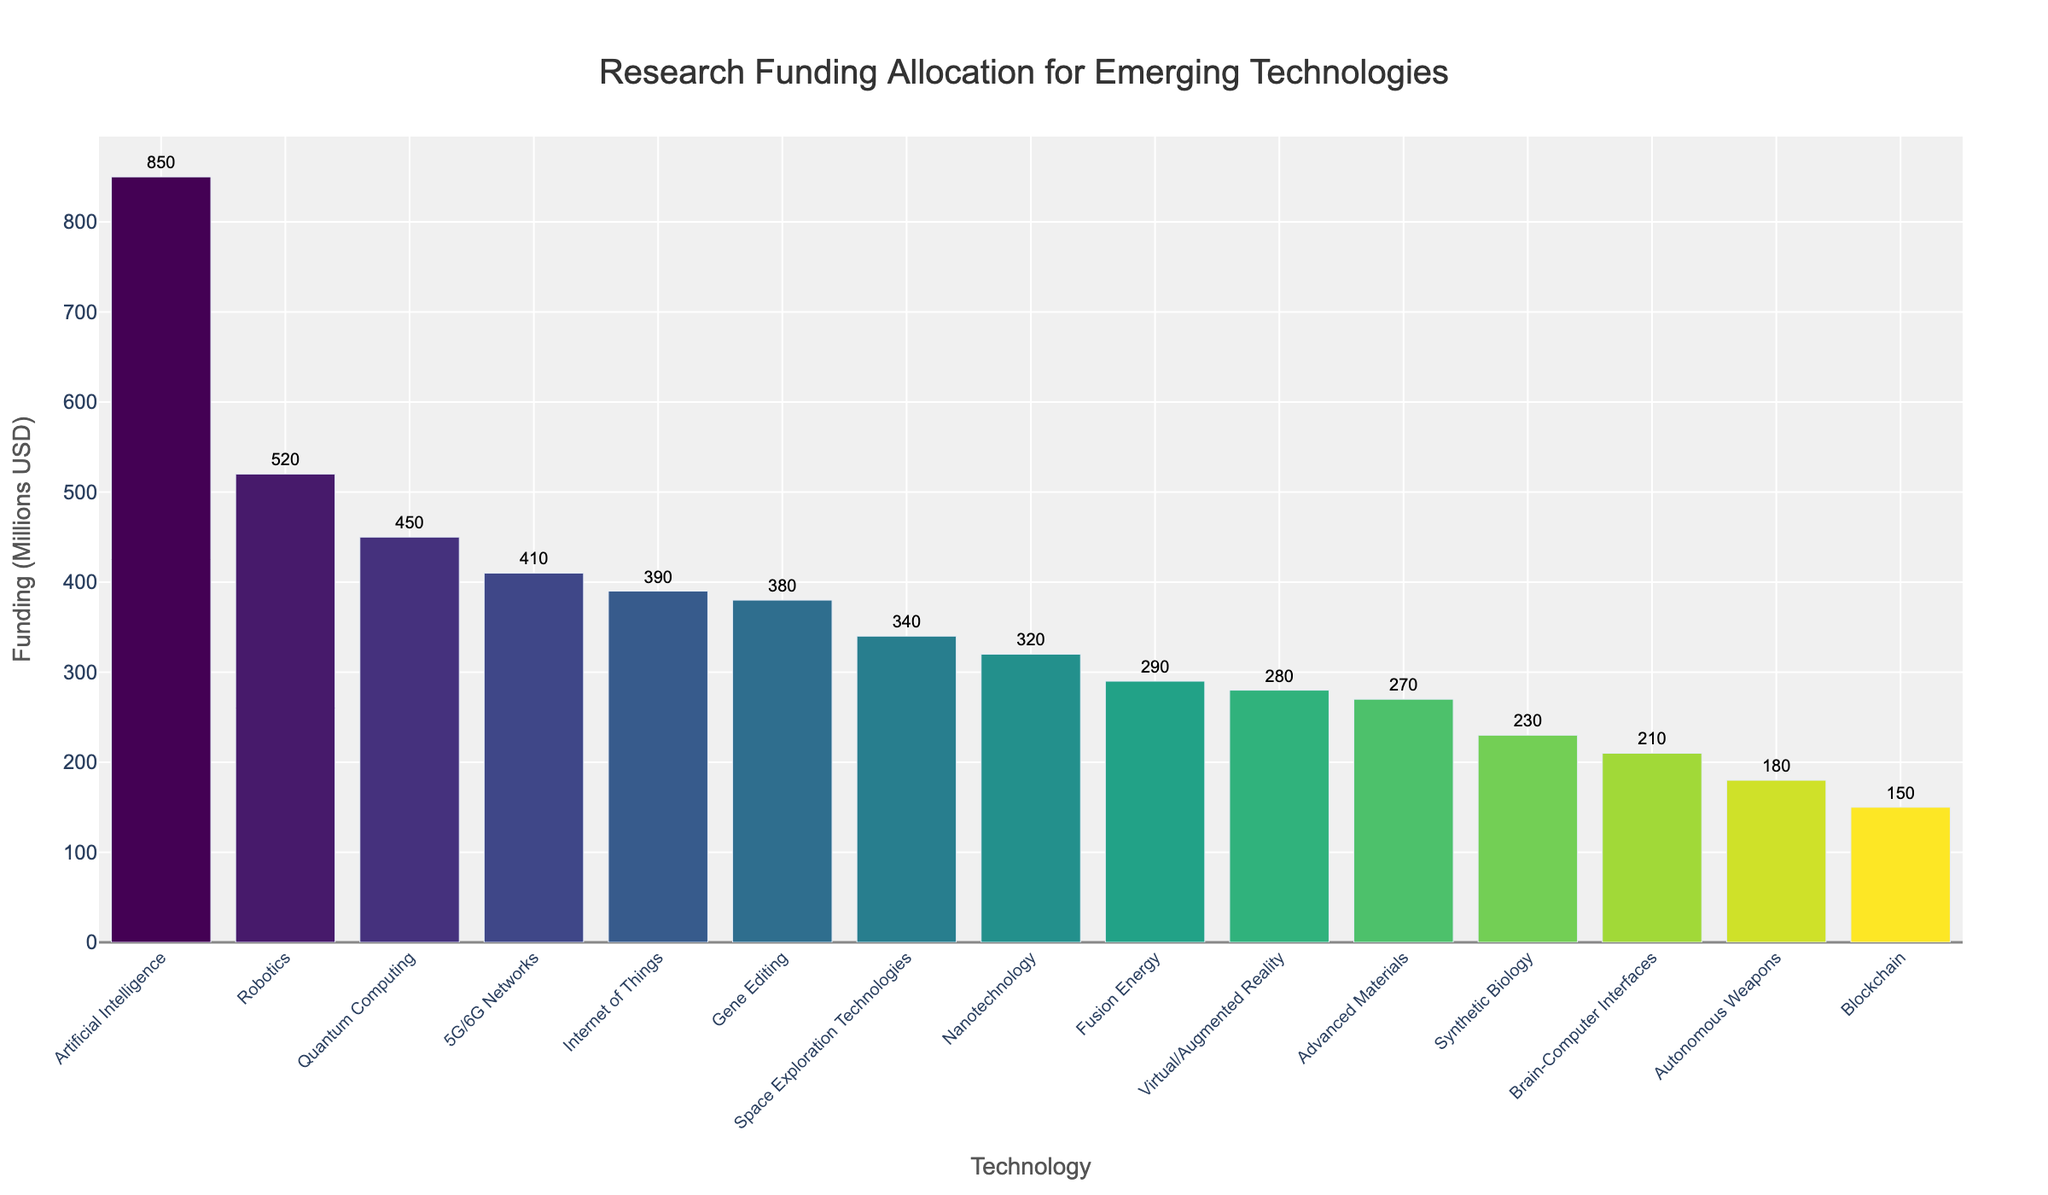what technology receives the most funding? The technology with the tallest bar in the bar chart represents the one that receives the most funding. In this case, it is ‘Artificial Intelligence’ with a funding amount of 850 million USD.
Answer: Artificial Intelligence Which technology receives the least amount of funding? The technology with the shortest bar in the bar chart represents the one that receives the least funding. This is ‘Blockchain’ with a funding amount of 150 million USD.
Answer: Blockchain How much more funding does Artificial Intelligence receive than Quantum Computing? The bar for Artificial Intelligence reaches 850 million USD, whereas the bar for Quantum Computing reaches 450 million USD. The difference is calculated as 850 - 450 = 400 million USD.
Answer: 400 million USD Compare the funding amounts for 5G/6G Networks and Internet of Things. Which one receives more and by how much? 5G/6G Networks receive 410 million USD, and Internet of Things receives 390 million USD. The difference is 410 - 390 = 20 million USD, with 5G/6G Networks receiving more funding.
Answer: 5G/6G Networks by 20 million USD What is the combined total funding for Nanotechnology, Robotics, and Virtual/Augmented Reality? The funding for each technology is as follows: Nanotechnology 320 million USD, Robotics 520 million USD, Virtual/Augmented Reality 280 million USD. The combined total is 320 + 520 + 280 = 1120 million USD.
Answer: 1120 million USD What is the average funding amount for the listed technologies? Sum the total funding for all technologies and divide by the number of technologies. The total sum is 850 + 450 + 380 + 210 + 180 + 320 + 520 + 280 + 150 + 410 + 390 + 230 + 270 + 290 + 340 = 5770 million USD. Dividing by the 15 technologies gives an average of 5770 / 15 ≈ 384.67 million USD.
Answer: 384.67 million USD Which technology group has similar funding levels and how close are those amounts? The funding levels for Fusion Energy and Space Exploration Technologies are close, with Fusion Energy at 290 million USD and Space Exploration Technologies at 340 million USD. The difference is 340 - 290 = 50 million USD.
Answer: Fusion Energy and Space Exploration Technologies, 50 million USD Which three technologies receive the lowest funding and what is their total funding amount? The three technologies with the lowest funding are Blockchain (150 million USD), Autonomous Weapons (180 million USD), and Brain-Computer Interfaces (210 million USD). The total funding amount is 150 + 180 + 210 = 540 million USD.
Answer: Blockchain, Autonomous Weapons, and Brain-Computer Interfaces, 540 million USD How does the funding for Synthetic Biology compare to that for Advanced Materials? Synthetic Biology receives 230 million USD, whereas Advanced Materials receive 270 million USD. Advanced Materials receive more funding by 270 - 230 = 40 million USD.
Answer: Advanced Materials by 40 million USD What is the median funding amount out of all the listed technologies? Sort the funding amounts in ascending order: 150, 180, 210, 230, 270, 280, 290, 320, 340, 380, 390, 410, 450, 520, 850. With fifteen data points, the median is the 8th value in the list, which is 320 million USD.
Answer: 320 million USD 